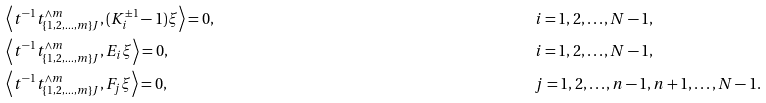Convert formula to latex. <formula><loc_0><loc_0><loc_500><loc_500>& \left \langle t ^ { - 1 } t _ { \{ 1 , 2 , \dots , m \} J } ^ { \wedge m } , ( K _ { i } ^ { \pm 1 } - 1 ) \xi \right \rangle = 0 , & & i = 1 , 2 , \dots , N - 1 , \\ & \left \langle t ^ { - 1 } t _ { \{ 1 , 2 , \dots , m \} J } ^ { \wedge m } , E _ { i } \xi \right \rangle = 0 , & & i = 1 , 2 , \dots , N - 1 , \\ & \left \langle t ^ { - 1 } t _ { \{ 1 , 2 , \dots , m \} J } ^ { \wedge m } , F _ { j } \xi \right \rangle = 0 , & & j = 1 , 2 , \dots , n - 1 , n + 1 , \dots , N - 1 .</formula> 